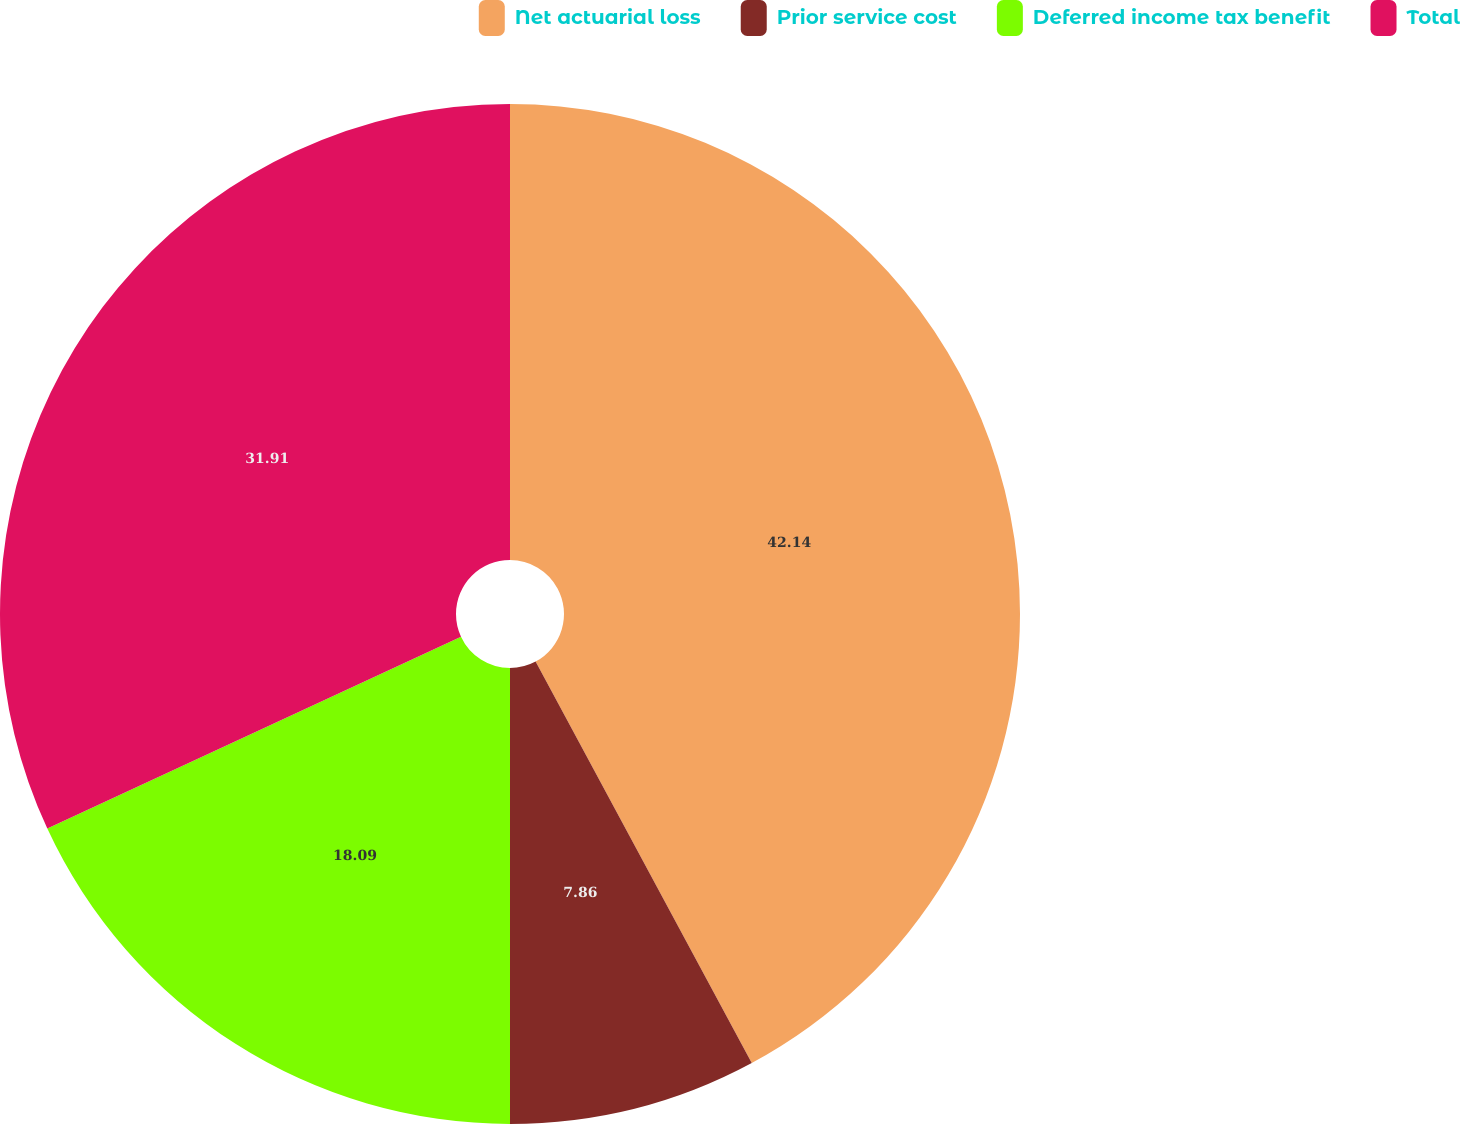<chart> <loc_0><loc_0><loc_500><loc_500><pie_chart><fcel>Net actuarial loss<fcel>Prior service cost<fcel>Deferred income tax benefit<fcel>Total<nl><fcel>42.14%<fcel>7.86%<fcel>18.09%<fcel>31.91%<nl></chart> 